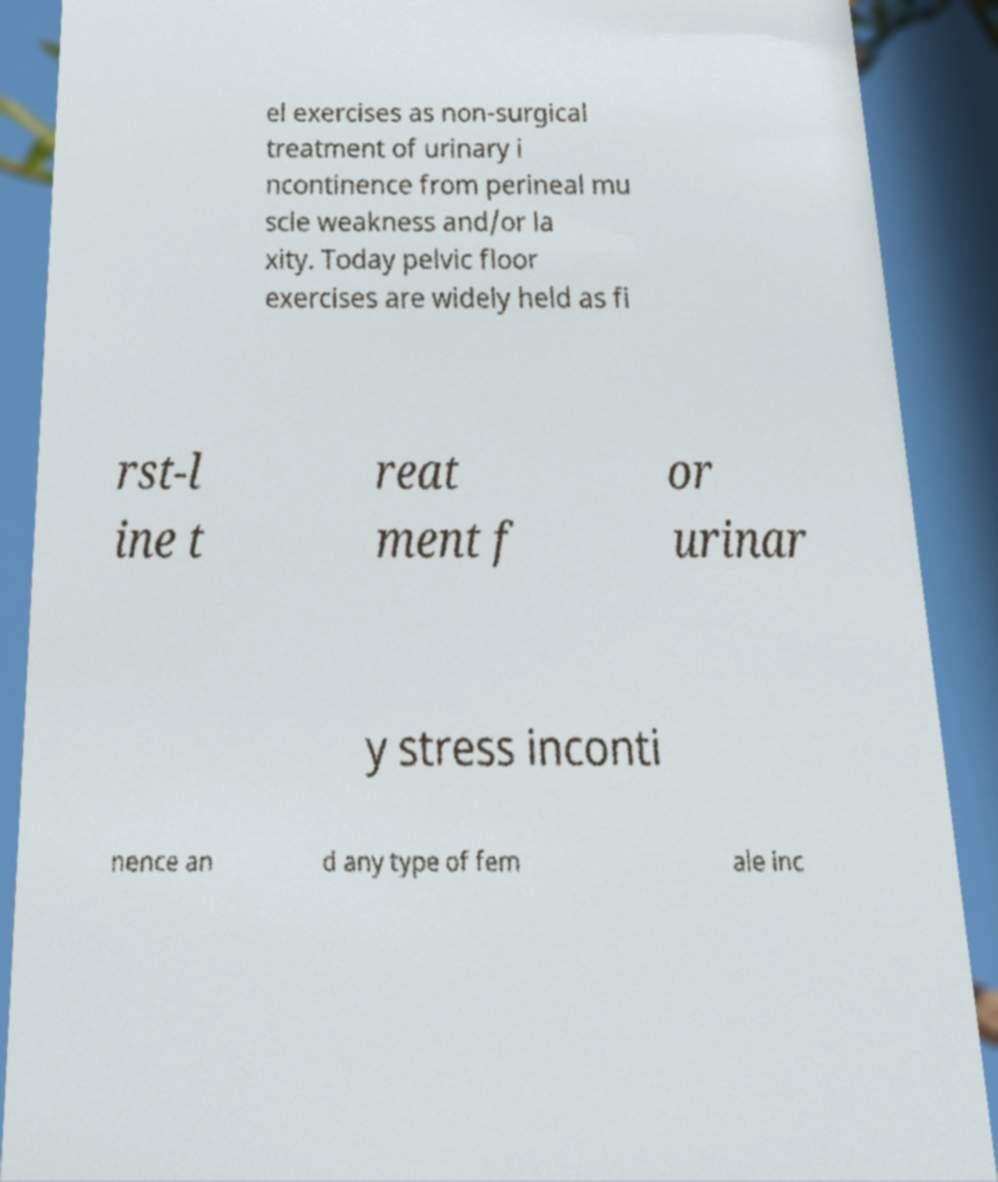There's text embedded in this image that I need extracted. Can you transcribe it verbatim? el exercises as non-surgical treatment of urinary i ncontinence from perineal mu scle weakness and/or la xity. Today pelvic floor exercises are widely held as fi rst-l ine t reat ment f or urinar y stress inconti nence an d any type of fem ale inc 